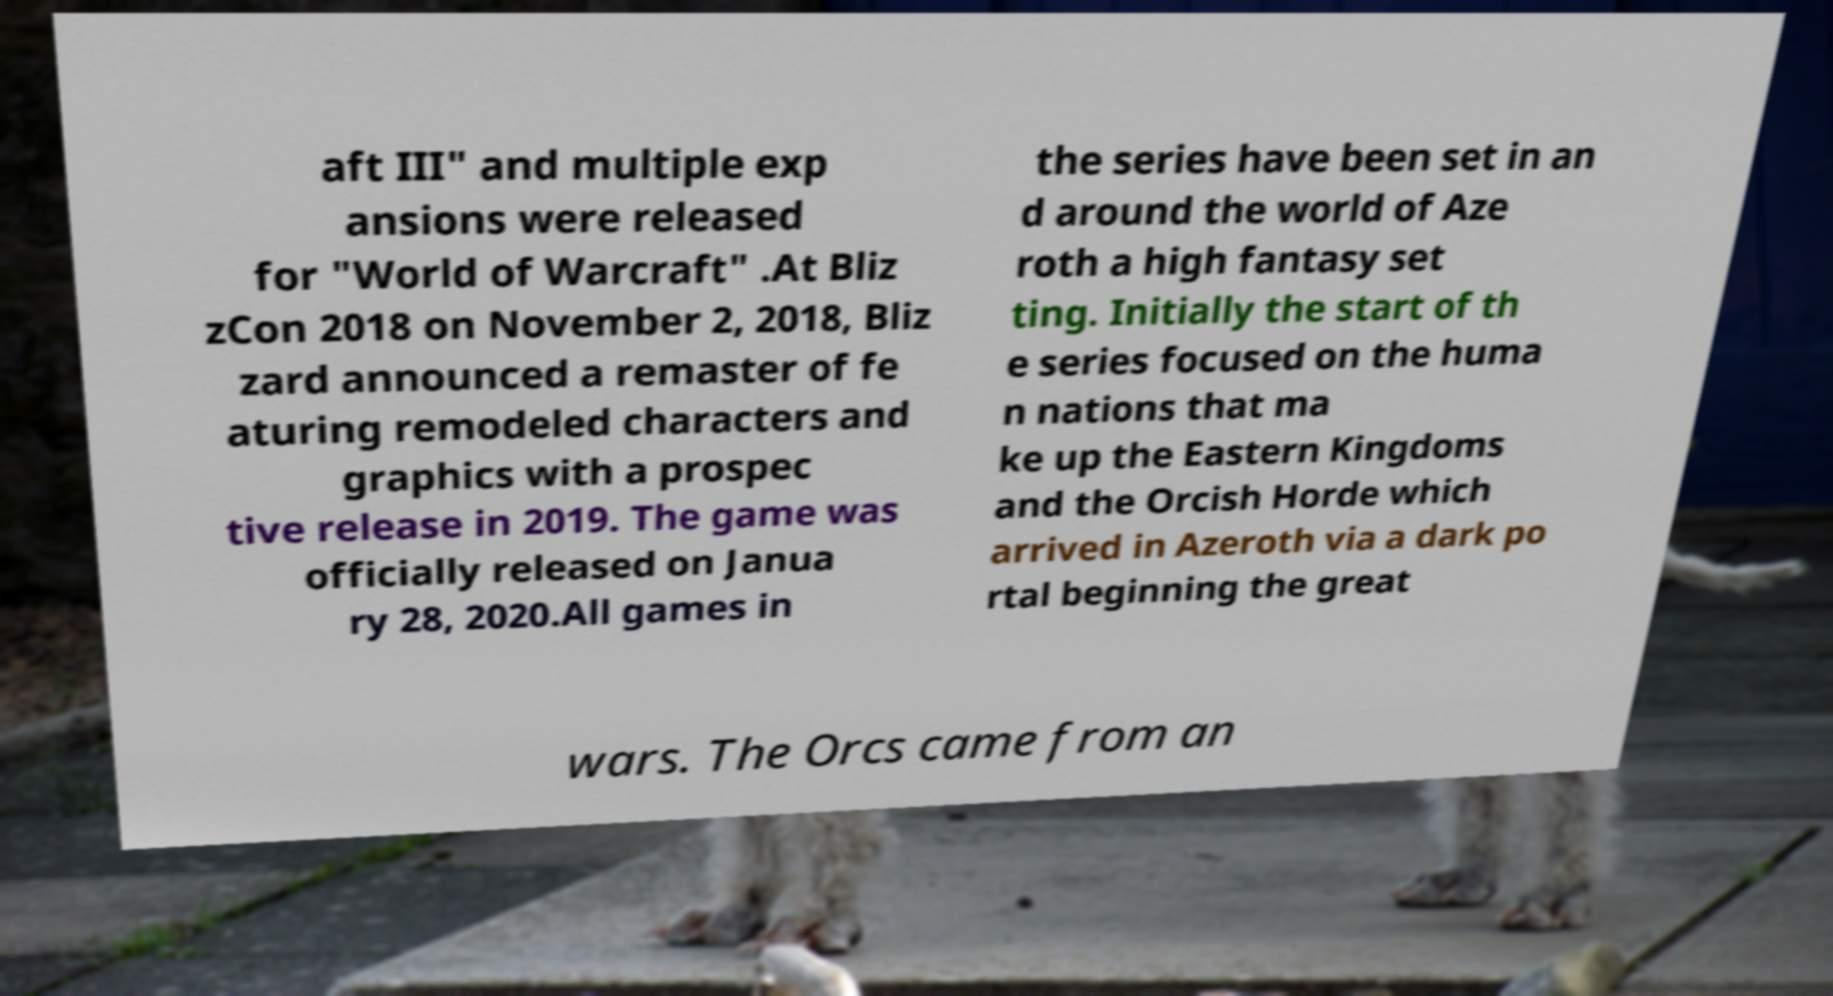There's text embedded in this image that I need extracted. Can you transcribe it verbatim? aft III" and multiple exp ansions were released for "World of Warcraft" .At Bliz zCon 2018 on November 2, 2018, Bliz zard announced a remaster of fe aturing remodeled characters and graphics with a prospec tive release in 2019. The game was officially released on Janua ry 28, 2020.All games in the series have been set in an d around the world of Aze roth a high fantasy set ting. Initially the start of th e series focused on the huma n nations that ma ke up the Eastern Kingdoms and the Orcish Horde which arrived in Azeroth via a dark po rtal beginning the great wars. The Orcs came from an 